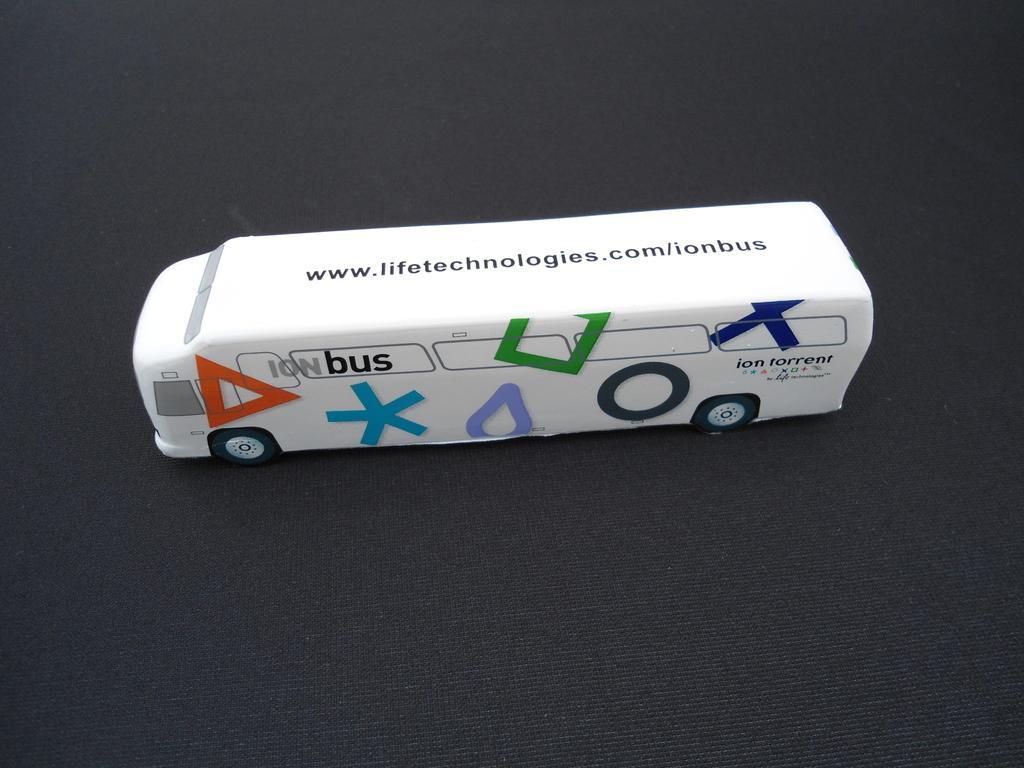Can you describe this image briefly? Hear I can see a white color toy which is looking like a bus on a black color sheet. 